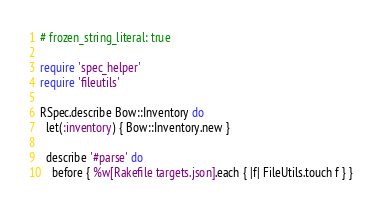<code> <loc_0><loc_0><loc_500><loc_500><_Ruby_># frozen_string_literal: true

require 'spec_helper'
require 'fileutils'

RSpec.describe Bow::Inventory do
  let(:inventory) { Bow::Inventory.new }

  describe '#parse' do
    before { %w[Rakefile targets.json].each { |f| FileUtils.touch f } }</code> 